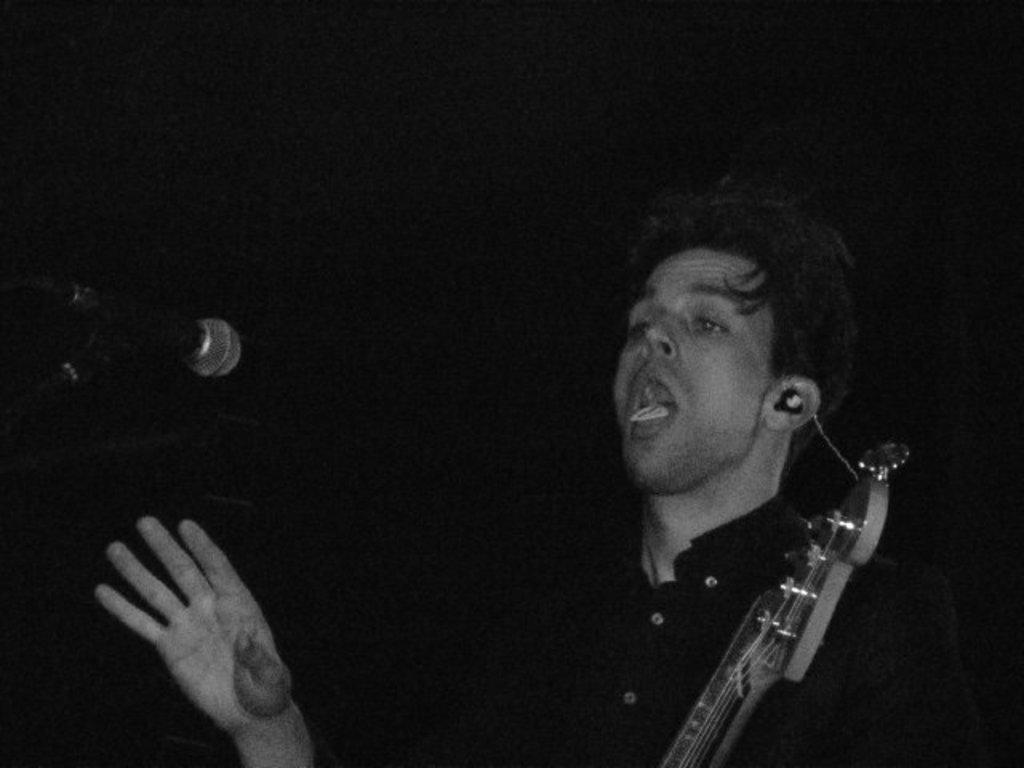What is the man in the image holding in his hands? The man is holding a guitar and a microphone. What might the man be doing in the image? The man might be performing or singing, given that he is holding a guitar and a microphone. Where is the seat located in the image? There is no seat present in the image. What type of list is the man holding in the image? The man is not holding a list in the image; he is holding a guitar and a microphone. 